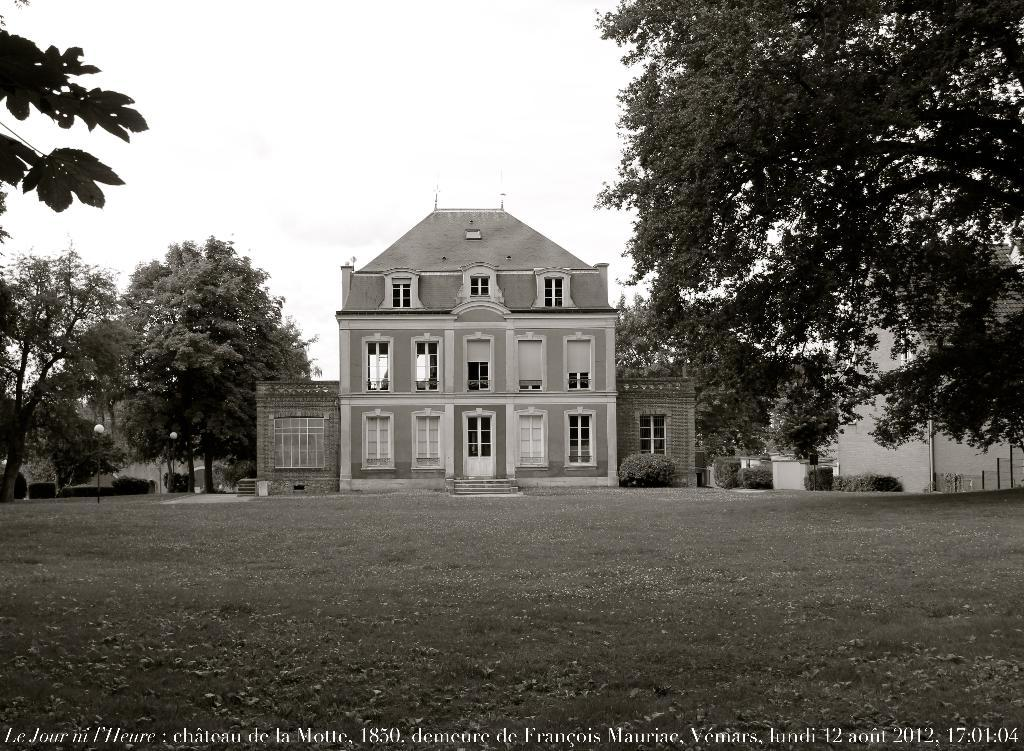What is the main structure in the middle of the image? There is a building in the middle of the image. What type of vegetation is present on either side of the building? There are trees on either side of the building. What color is the text at the bottom of the image? The text at the bottom of the image is in white color. What can be seen at the top of the image? The sky is visible at the top of the image. What type of language is spoken by the trees in the image? The trees in the image do not speak any language, as they are inanimate objects. 